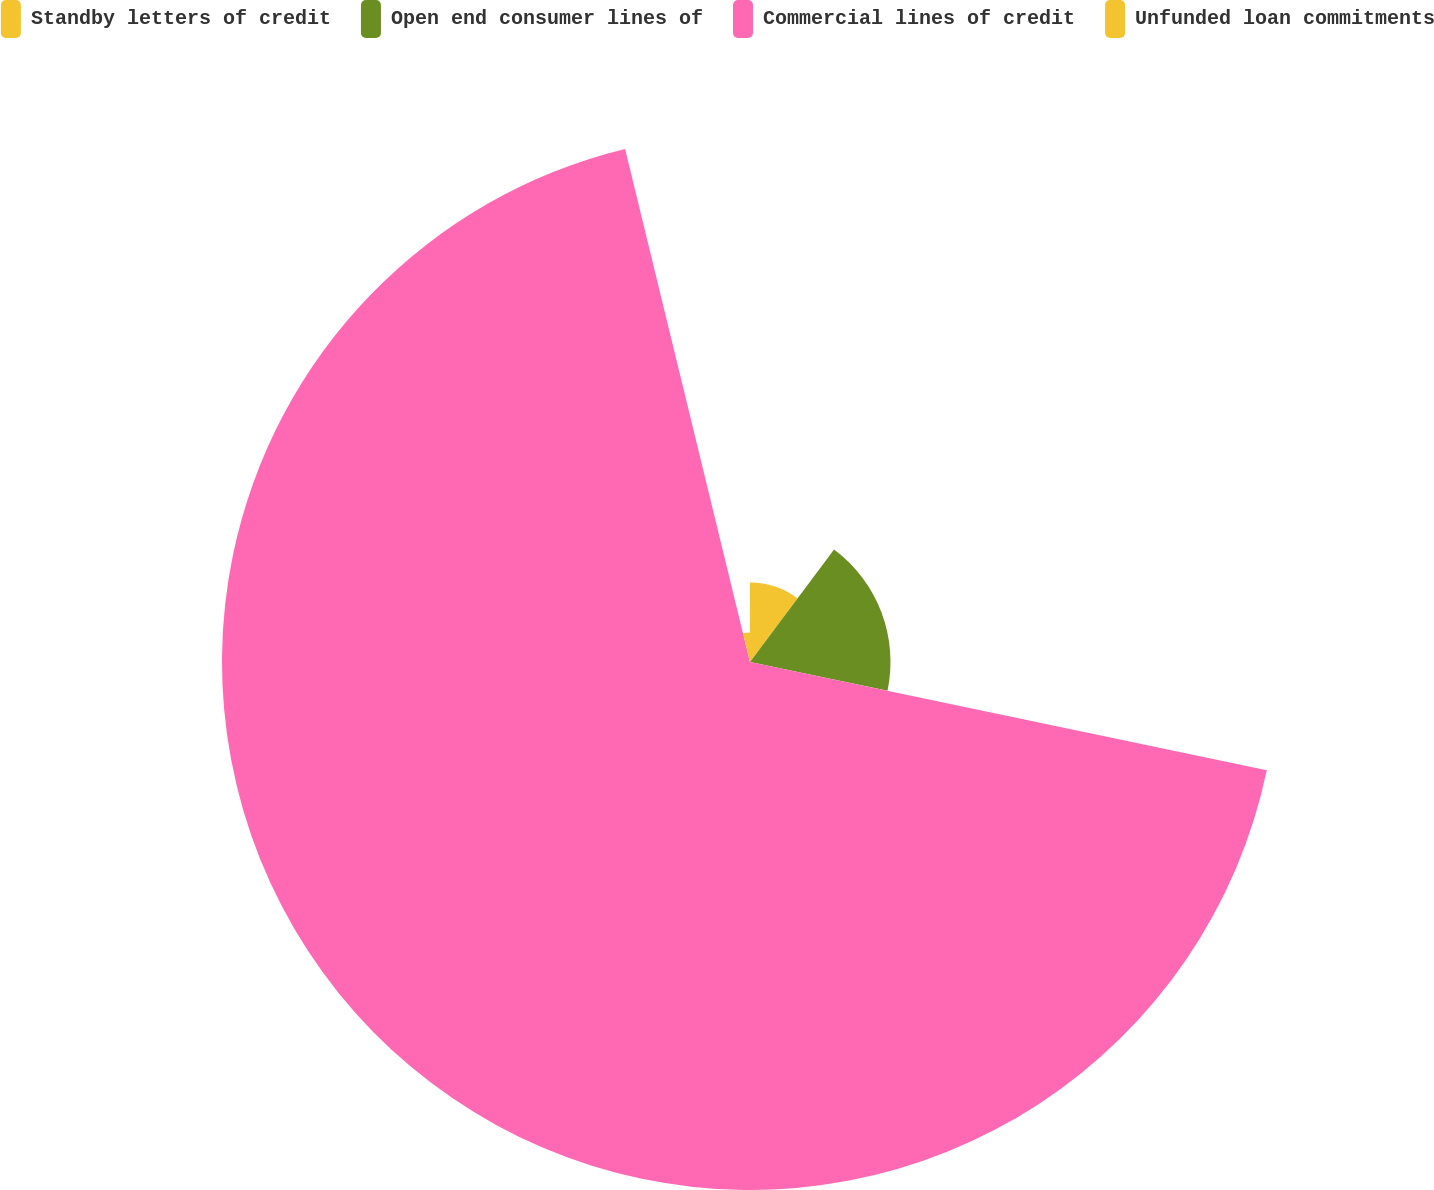Convert chart to OTSL. <chart><loc_0><loc_0><loc_500><loc_500><pie_chart><fcel>Standby letters of credit<fcel>Open end consumer lines of<fcel>Commercial lines of credit<fcel>Unfunded loan commitments<nl><fcel>10.21%<fcel>18.07%<fcel>67.91%<fcel>3.8%<nl></chart> 